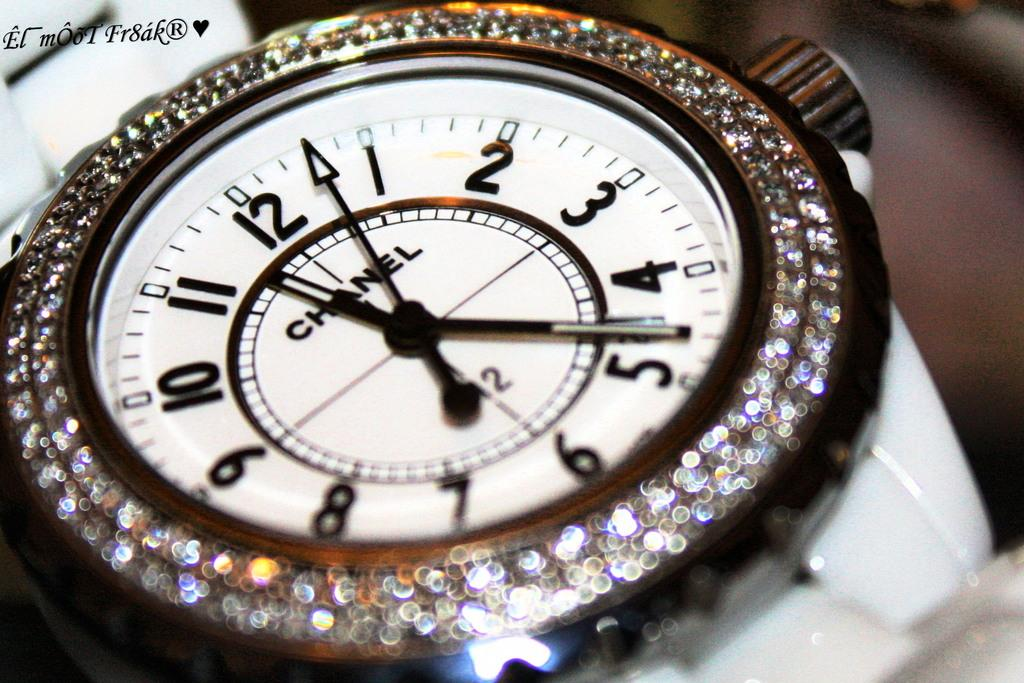<image>
Share a concise interpretation of the image provided. A Chanel watch has a white face surrounded by diamonds. 